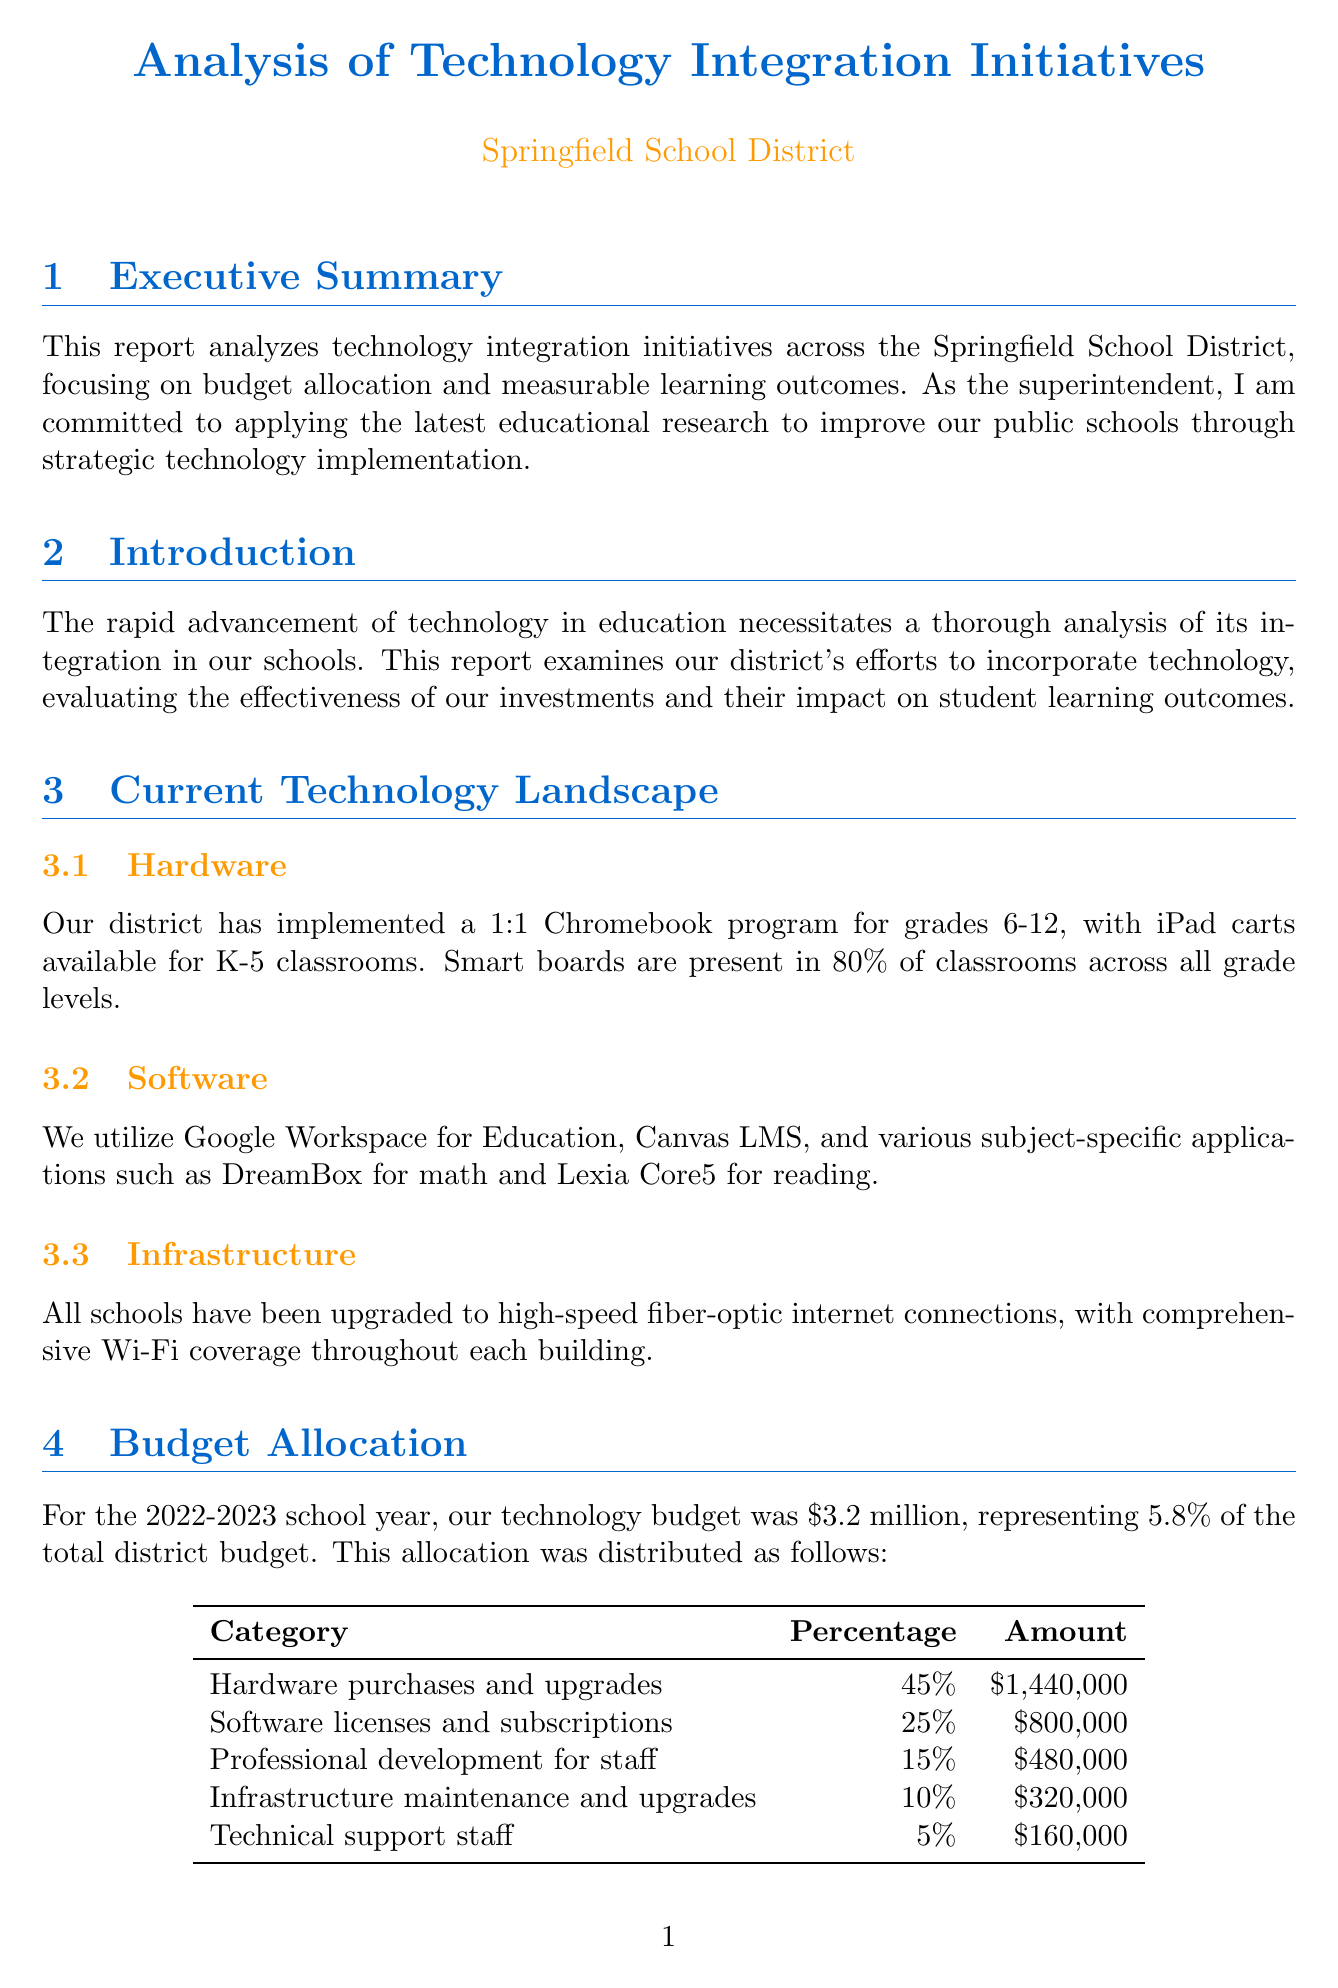What is the total technology budget for the 2022-2023 school year? The total technology budget for the 2022-2023 school year is stated in the Budget Allocation section.
Answer: $3.2 million What percentage of the total district budget does the technology budget represent? The report indicates that the technology budget represents 5.8% of the total district budget in the Budget Allocation section.
Answer: 5.8% Which school implemented a coding program using Scratch? The document lists Lincoln Elementary School as the school that implemented a coding program using Scratch under the Case Studies section.
Answer: Lincoln Elementary School What was the increase in math proficiency after the 1:1 Chromebook program implementation? The increase in math proficiency is noted in the Measurable Learning Outcomes section related to Standardized Test Scores.
Answer: 7% What is the main challenge mentioned in the Challenges and Future Directions section? The report highlights several challenges in the Challenges and Future Directions section, including ensuring equitable access for all students.
Answer: Ensuring equitable access What type of learning software showed a notable growth in students’ math skills? The report mentions adaptive learning software that contributed to increased math growth in the Measurable Learning Outcomes section.
Answer: DreamBox What was the increase in student engagement during technology-integrated lessons? The document states that there was a 25% increase in student engagement during technology-integrated lessons, as found in the Measurable Learning Outcomes section.
Answer: 25% How much was allocated for professional development for staff? The budget breakdown for professional development for staff can be found in the Budget Allocation section.
Answer: $480,000 What is one future direction mentioned for technology integration initiatives? The report lists future directions in the Challenges and Future Directions section, including exploring artificial intelligence applications in education.
Answer: Exploring artificial intelligence applications in education 